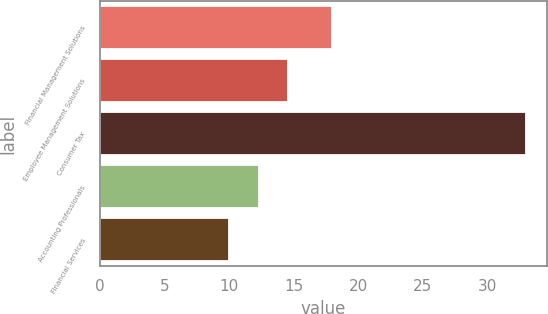<chart> <loc_0><loc_0><loc_500><loc_500><bar_chart><fcel>Financial Management Solutions<fcel>Employee Management Solutions<fcel>Consumer Tax<fcel>Accounting Professionals<fcel>Financial Services<nl><fcel>18<fcel>14.6<fcel>33<fcel>12.3<fcel>10<nl></chart> 